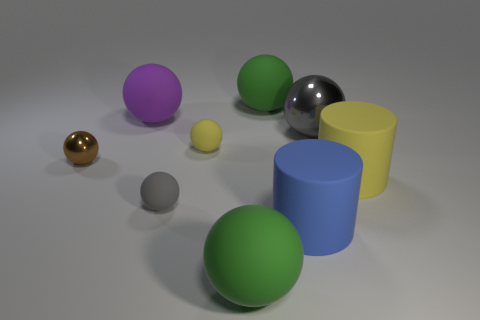There is a purple thing that is the same shape as the tiny gray rubber thing; what size is it?
Offer a very short reply. Large. What is the shape of the green thing that is behind the large gray sphere that is to the right of the large purple thing?
Offer a very short reply. Sphere. What is the shape of the big blue thing to the right of the brown metallic thing?
Provide a succinct answer. Cylinder. What number of small balls have the same color as the large metal object?
Make the answer very short. 1. What color is the big metallic object?
Provide a short and direct response. Gray. How many big yellow things are left of the green matte object that is in front of the gray metal sphere?
Your response must be concise. 0. Do the brown object and the object that is behind the purple matte sphere have the same size?
Offer a very short reply. No. Is the size of the gray metallic sphere the same as the blue rubber thing?
Offer a terse response. Yes. Is there a matte cylinder of the same size as the gray matte thing?
Make the answer very short. No. There is a yellow object that is on the left side of the blue thing; what is its material?
Keep it short and to the point. Rubber. 